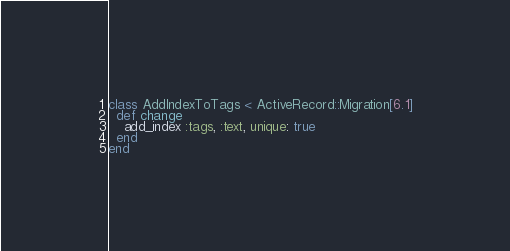Convert code to text. <code><loc_0><loc_0><loc_500><loc_500><_Ruby_>class AddIndexToTags < ActiveRecord::Migration[6.1]
  def change
    add_index :tags, :text, unique: true
  end
end
</code> 